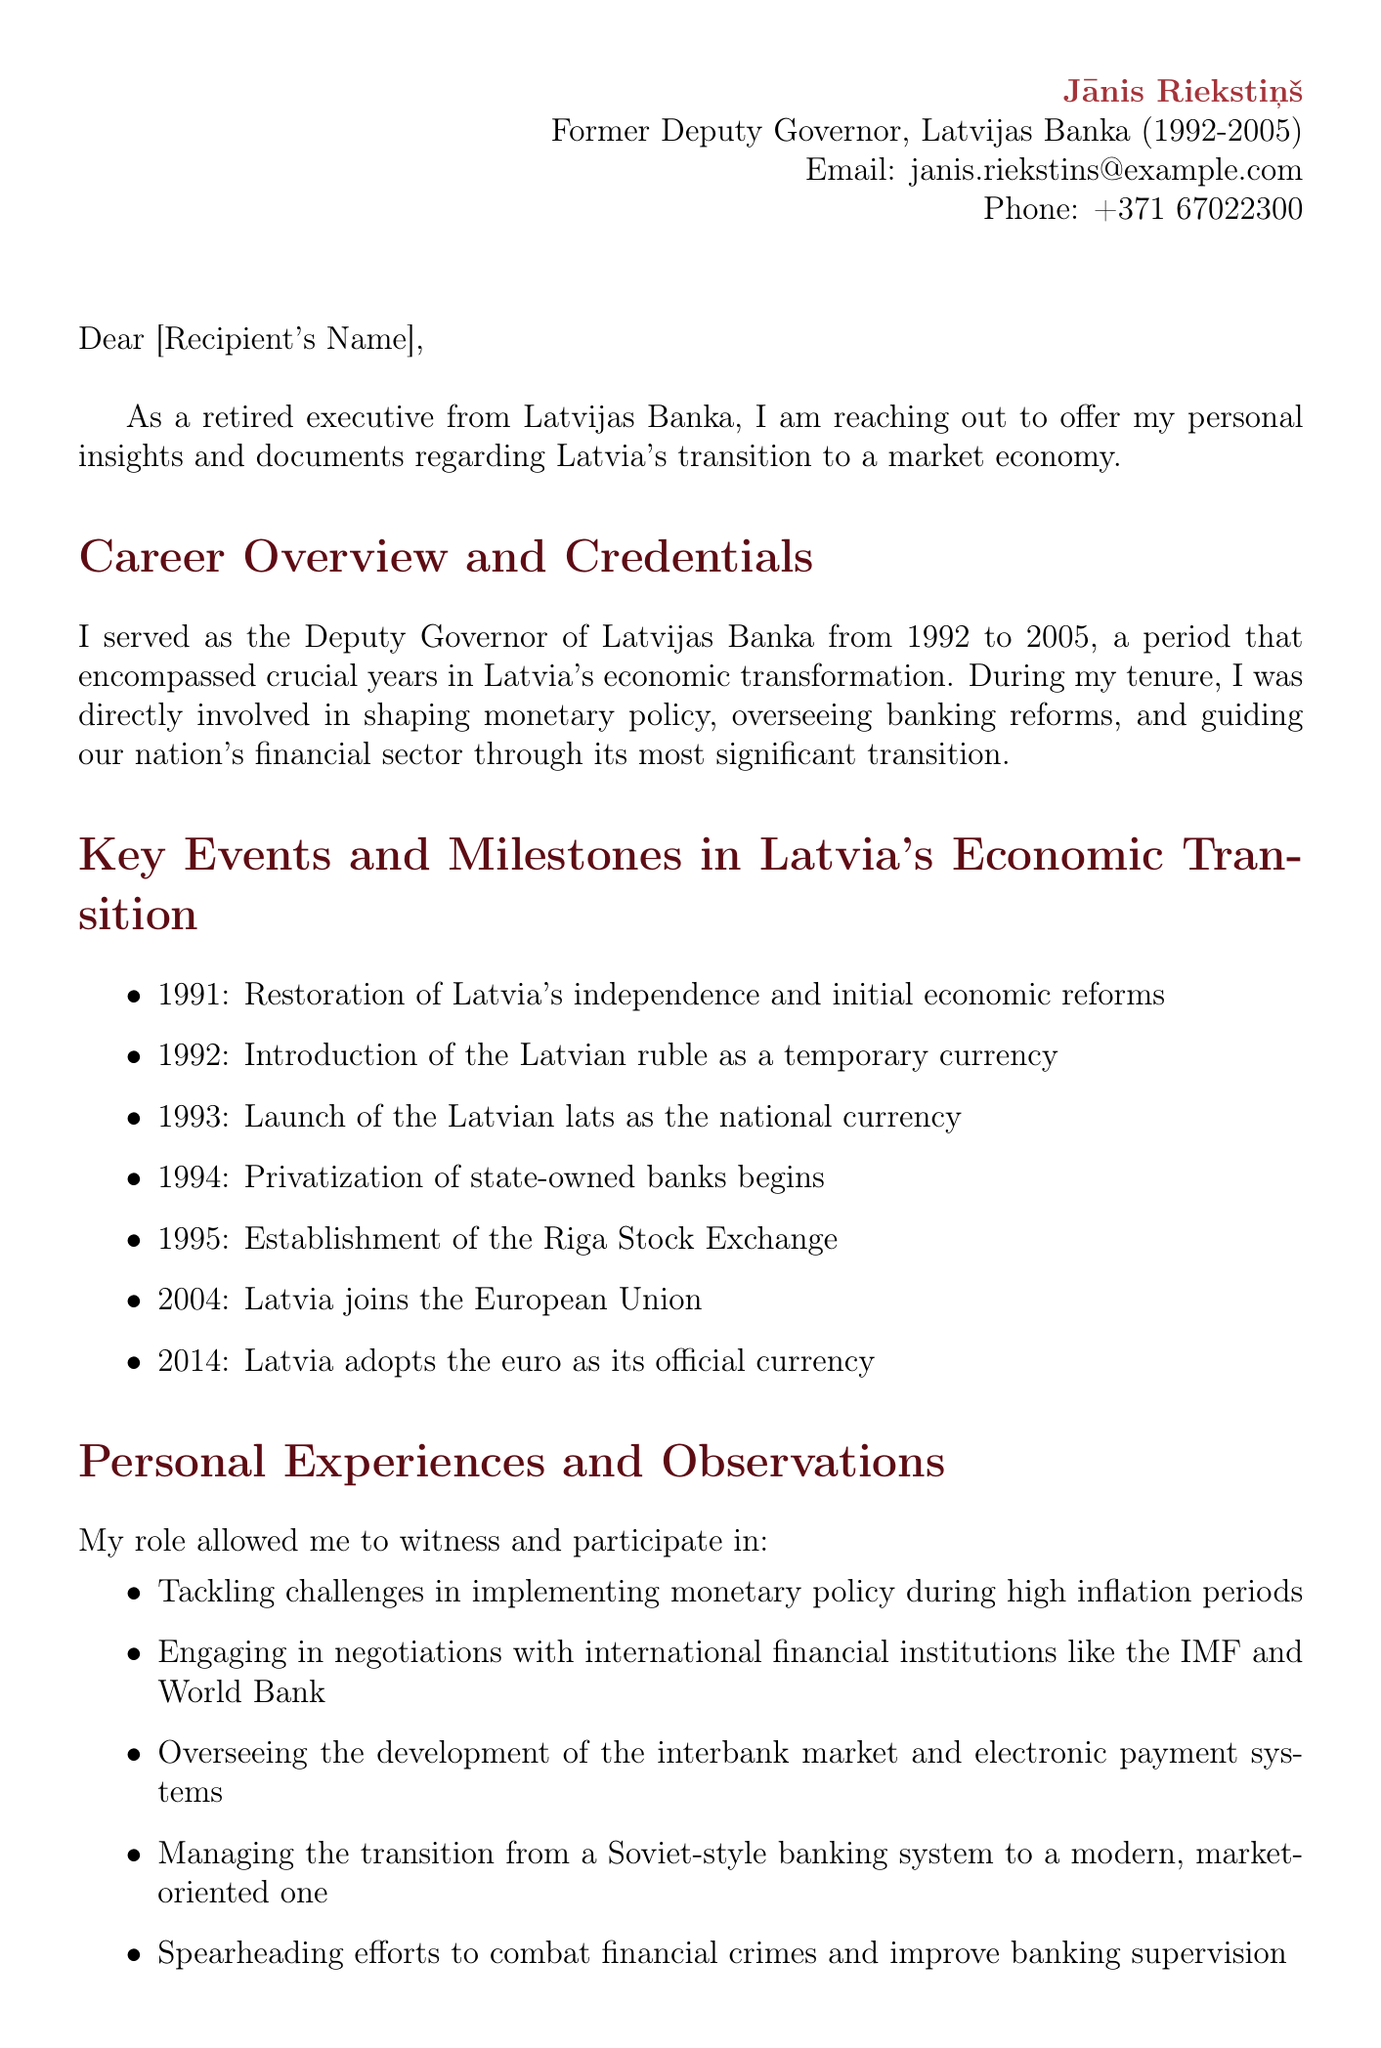What position did Jānis Riekstiņš hold? Jānis Riekstiņš served as the Deputy Governor of Latvijas Banka, which is stated in the sender details.
Answer: Deputy Governor Which currency was launched in 1993? The document lists the launch of the Latvian lats as the national currency in the key events section.
Answer: Latvian lats What year did Latvia join the European Union? The document specifies that Latvia joined the European Union in 2004 as one of the key events.
Answer: 2004 What document type is being offered for sharing? The letter mentions sharing internal memos on currency reform strategies in the section about specific documents and resources.
Answer: Internal memos Name one of the personal challenges mentioned. The personal experiences section includes challenges in implementing monetary policy during high inflation periods.
Answer: High inflation What organization is mentioned alongside the World Bank in negotiations? The document refers to the IMF in the context of negotiations with international financial institutions.
Answer: IMF What type of collaboration is Jānis Riekstiņš open to? The letter expresses openness to participating in oral history interviews regarding the banking sector's transformation.
Answer: Oral history interviews How many key events are listed in the document? By counting the items in the key events section of the document, one can determine the total number.
Answer: Seven 